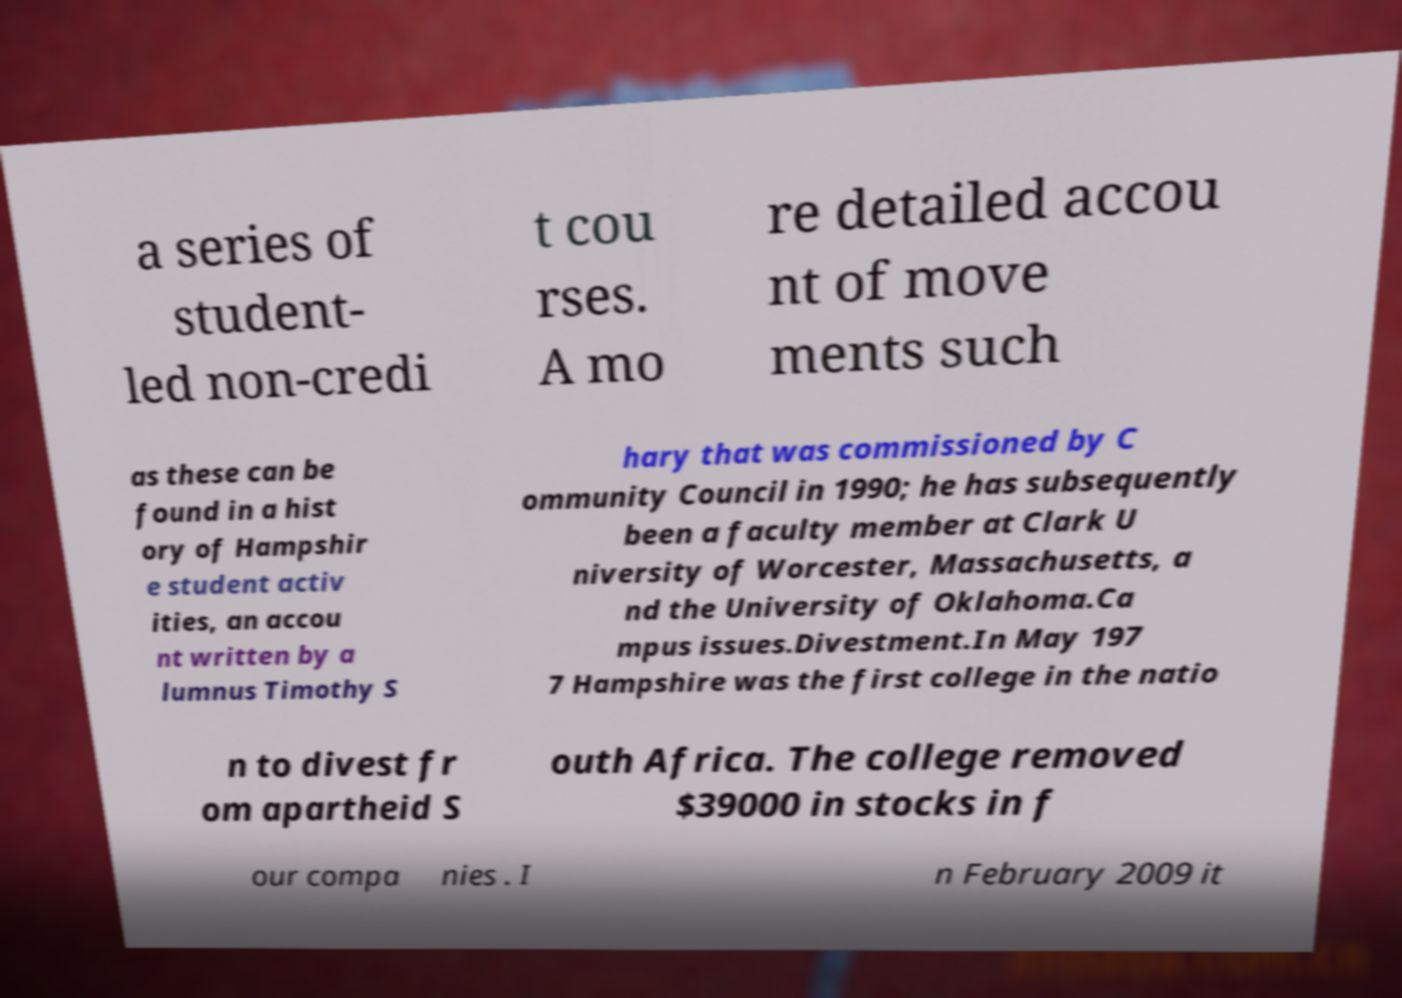For documentation purposes, I need the text within this image transcribed. Could you provide that? a series of student- led non-credi t cou rses. A mo re detailed accou nt of move ments such as these can be found in a hist ory of Hampshir e student activ ities, an accou nt written by a lumnus Timothy S hary that was commissioned by C ommunity Council in 1990; he has subsequently been a faculty member at Clark U niversity of Worcester, Massachusetts, a nd the University of Oklahoma.Ca mpus issues.Divestment.In May 197 7 Hampshire was the first college in the natio n to divest fr om apartheid S outh Africa. The college removed $39000 in stocks in f our compa nies . I n February 2009 it 